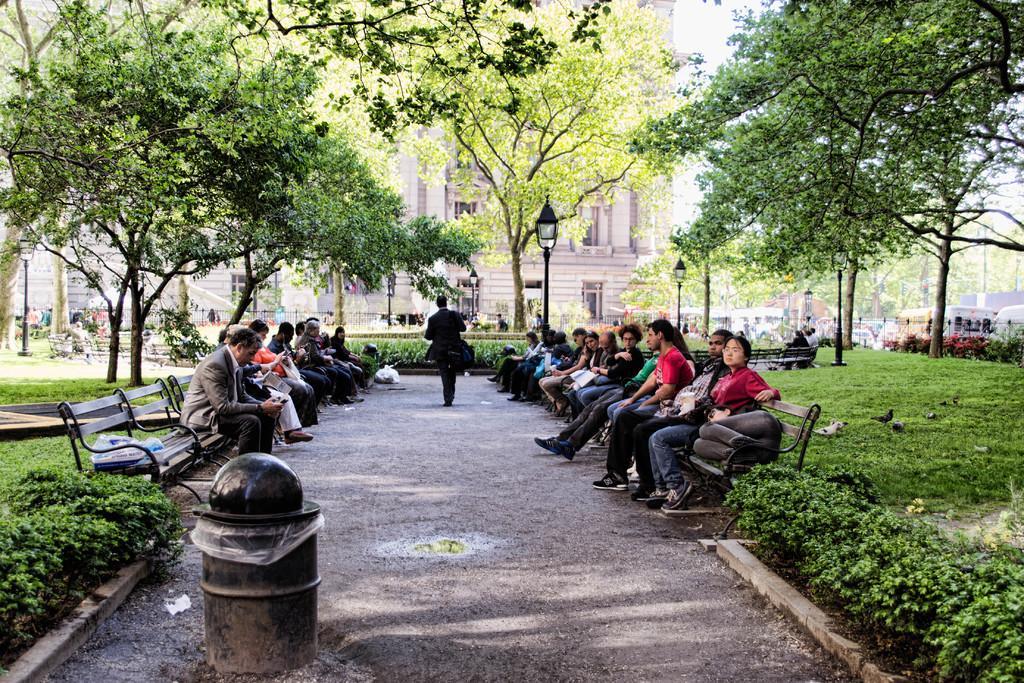Can you describe this image briefly? In the center of the image we can see one dustbin. On the dustbin, we can see one black color object. And we can see a few people are sitting on the benches and one person walking on the road. In the background, we can see the sky, trees, poles, plants, grass, benches, one traffic light, one building, windows etc. 